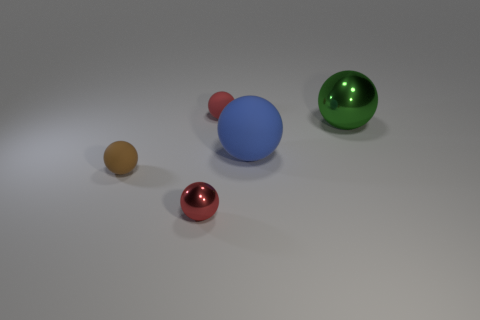Which is the largest sphere and what is its color? The largest sphere in the image is the blue one, which has a smooth, glossy finish. How is the lighting affecting the appearance of the spheres? The lighting in the image is soft and appears to come from above, creating gentle shadows beneath each sphere and giving them a three-dimensional look. The glossy surfaces reflect the light, adding highlights that enhance their spherical form. 